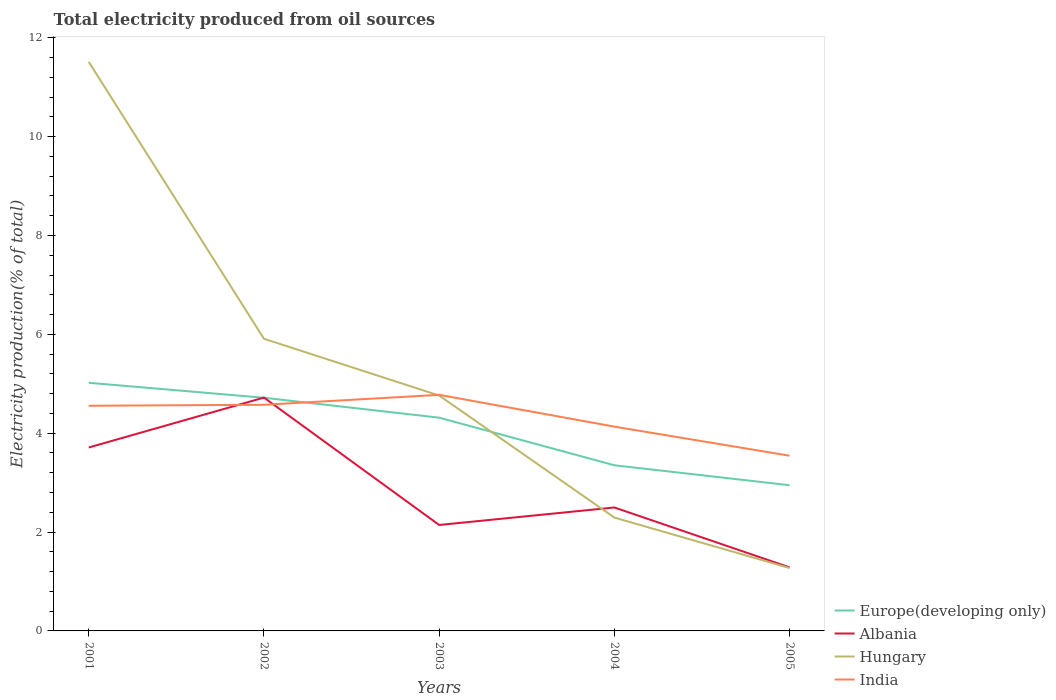Does the line corresponding to Europe(developing only) intersect with the line corresponding to Hungary?
Offer a very short reply. Yes. Is the number of lines equal to the number of legend labels?
Provide a short and direct response. Yes. Across all years, what is the maximum total electricity produced in India?
Offer a terse response. 3.54. In which year was the total electricity produced in Hungary maximum?
Keep it short and to the point. 2005. What is the total total electricity produced in India in the graph?
Offer a terse response. 0.64. What is the difference between the highest and the second highest total electricity produced in India?
Provide a succinct answer. 1.23. What is the difference between the highest and the lowest total electricity produced in Albania?
Make the answer very short. 2. Is the total electricity produced in Albania strictly greater than the total electricity produced in India over the years?
Your answer should be very brief. No. How many years are there in the graph?
Your answer should be compact. 5. What is the difference between two consecutive major ticks on the Y-axis?
Keep it short and to the point. 2. Are the values on the major ticks of Y-axis written in scientific E-notation?
Your answer should be very brief. No. Does the graph contain any zero values?
Your answer should be very brief. No. Where does the legend appear in the graph?
Ensure brevity in your answer.  Bottom right. How many legend labels are there?
Give a very brief answer. 4. What is the title of the graph?
Offer a terse response. Total electricity produced from oil sources. Does "San Marino" appear as one of the legend labels in the graph?
Provide a short and direct response. No. What is the label or title of the X-axis?
Ensure brevity in your answer.  Years. What is the Electricity production(% of total) in Europe(developing only) in 2001?
Your answer should be very brief. 5.02. What is the Electricity production(% of total) in Albania in 2001?
Give a very brief answer. 3.71. What is the Electricity production(% of total) of Hungary in 2001?
Give a very brief answer. 11.51. What is the Electricity production(% of total) in India in 2001?
Offer a very short reply. 4.55. What is the Electricity production(% of total) in Europe(developing only) in 2002?
Keep it short and to the point. 4.72. What is the Electricity production(% of total) in Albania in 2002?
Make the answer very short. 4.72. What is the Electricity production(% of total) in Hungary in 2002?
Keep it short and to the point. 5.91. What is the Electricity production(% of total) in India in 2002?
Your response must be concise. 4.57. What is the Electricity production(% of total) of Europe(developing only) in 2003?
Make the answer very short. 4.31. What is the Electricity production(% of total) of Albania in 2003?
Keep it short and to the point. 2.14. What is the Electricity production(% of total) of Hungary in 2003?
Give a very brief answer. 4.76. What is the Electricity production(% of total) in India in 2003?
Your answer should be compact. 4.78. What is the Electricity production(% of total) of Europe(developing only) in 2004?
Keep it short and to the point. 3.35. What is the Electricity production(% of total) in Albania in 2004?
Offer a very short reply. 2.5. What is the Electricity production(% of total) of Hungary in 2004?
Offer a very short reply. 2.29. What is the Electricity production(% of total) in India in 2004?
Your answer should be compact. 4.13. What is the Electricity production(% of total) of Europe(developing only) in 2005?
Offer a very short reply. 2.95. What is the Electricity production(% of total) of Albania in 2005?
Your answer should be compact. 1.29. What is the Electricity production(% of total) in Hungary in 2005?
Provide a short and direct response. 1.27. What is the Electricity production(% of total) in India in 2005?
Provide a short and direct response. 3.54. Across all years, what is the maximum Electricity production(% of total) in Europe(developing only)?
Offer a terse response. 5.02. Across all years, what is the maximum Electricity production(% of total) of Albania?
Provide a succinct answer. 4.72. Across all years, what is the maximum Electricity production(% of total) in Hungary?
Offer a very short reply. 11.51. Across all years, what is the maximum Electricity production(% of total) of India?
Give a very brief answer. 4.78. Across all years, what is the minimum Electricity production(% of total) in Europe(developing only)?
Offer a terse response. 2.95. Across all years, what is the minimum Electricity production(% of total) in Albania?
Make the answer very short. 1.29. Across all years, what is the minimum Electricity production(% of total) of Hungary?
Your answer should be very brief. 1.27. Across all years, what is the minimum Electricity production(% of total) of India?
Provide a succinct answer. 3.54. What is the total Electricity production(% of total) of Europe(developing only) in the graph?
Your response must be concise. 20.35. What is the total Electricity production(% of total) of Albania in the graph?
Your answer should be compact. 14.36. What is the total Electricity production(% of total) of Hungary in the graph?
Your answer should be very brief. 25.75. What is the total Electricity production(% of total) in India in the graph?
Provide a short and direct response. 21.58. What is the difference between the Electricity production(% of total) in Europe(developing only) in 2001 and that in 2002?
Your answer should be very brief. 0.3. What is the difference between the Electricity production(% of total) in Albania in 2001 and that in 2002?
Offer a very short reply. -1.01. What is the difference between the Electricity production(% of total) in Hungary in 2001 and that in 2002?
Your response must be concise. 5.6. What is the difference between the Electricity production(% of total) in India in 2001 and that in 2002?
Your answer should be very brief. -0.02. What is the difference between the Electricity production(% of total) of Europe(developing only) in 2001 and that in 2003?
Ensure brevity in your answer.  0.71. What is the difference between the Electricity production(% of total) of Albania in 2001 and that in 2003?
Keep it short and to the point. 1.57. What is the difference between the Electricity production(% of total) of Hungary in 2001 and that in 2003?
Offer a very short reply. 6.75. What is the difference between the Electricity production(% of total) in India in 2001 and that in 2003?
Offer a very short reply. -0.22. What is the difference between the Electricity production(% of total) in Europe(developing only) in 2001 and that in 2004?
Provide a short and direct response. 1.67. What is the difference between the Electricity production(% of total) in Albania in 2001 and that in 2004?
Offer a very short reply. 1.21. What is the difference between the Electricity production(% of total) of Hungary in 2001 and that in 2004?
Keep it short and to the point. 9.22. What is the difference between the Electricity production(% of total) of India in 2001 and that in 2004?
Give a very brief answer. 0.42. What is the difference between the Electricity production(% of total) of Europe(developing only) in 2001 and that in 2005?
Your response must be concise. 2.07. What is the difference between the Electricity production(% of total) of Albania in 2001 and that in 2005?
Give a very brief answer. 2.42. What is the difference between the Electricity production(% of total) in Hungary in 2001 and that in 2005?
Keep it short and to the point. 10.24. What is the difference between the Electricity production(% of total) in India in 2001 and that in 2005?
Your response must be concise. 1.01. What is the difference between the Electricity production(% of total) of Europe(developing only) in 2002 and that in 2003?
Your answer should be very brief. 0.4. What is the difference between the Electricity production(% of total) in Albania in 2002 and that in 2003?
Offer a terse response. 2.58. What is the difference between the Electricity production(% of total) in Hungary in 2002 and that in 2003?
Provide a succinct answer. 1.15. What is the difference between the Electricity production(% of total) of India in 2002 and that in 2003?
Keep it short and to the point. -0.2. What is the difference between the Electricity production(% of total) of Europe(developing only) in 2002 and that in 2004?
Keep it short and to the point. 1.37. What is the difference between the Electricity production(% of total) of Albania in 2002 and that in 2004?
Your answer should be very brief. 2.22. What is the difference between the Electricity production(% of total) of Hungary in 2002 and that in 2004?
Give a very brief answer. 3.62. What is the difference between the Electricity production(% of total) of India in 2002 and that in 2004?
Give a very brief answer. 0.44. What is the difference between the Electricity production(% of total) of Europe(developing only) in 2002 and that in 2005?
Provide a short and direct response. 1.77. What is the difference between the Electricity production(% of total) in Albania in 2002 and that in 2005?
Give a very brief answer. 3.43. What is the difference between the Electricity production(% of total) in Hungary in 2002 and that in 2005?
Offer a terse response. 4.64. What is the difference between the Electricity production(% of total) in India in 2002 and that in 2005?
Ensure brevity in your answer.  1.03. What is the difference between the Electricity production(% of total) of Albania in 2003 and that in 2004?
Provide a short and direct response. -0.35. What is the difference between the Electricity production(% of total) of Hungary in 2003 and that in 2004?
Give a very brief answer. 2.47. What is the difference between the Electricity production(% of total) in India in 2003 and that in 2004?
Keep it short and to the point. 0.64. What is the difference between the Electricity production(% of total) in Europe(developing only) in 2003 and that in 2005?
Offer a very short reply. 1.37. What is the difference between the Electricity production(% of total) in Albania in 2003 and that in 2005?
Keep it short and to the point. 0.86. What is the difference between the Electricity production(% of total) in Hungary in 2003 and that in 2005?
Give a very brief answer. 3.49. What is the difference between the Electricity production(% of total) in India in 2003 and that in 2005?
Ensure brevity in your answer.  1.23. What is the difference between the Electricity production(% of total) in Europe(developing only) in 2004 and that in 2005?
Your answer should be very brief. 0.4. What is the difference between the Electricity production(% of total) of Albania in 2004 and that in 2005?
Give a very brief answer. 1.21. What is the difference between the Electricity production(% of total) in Hungary in 2004 and that in 2005?
Your response must be concise. 1.02. What is the difference between the Electricity production(% of total) in India in 2004 and that in 2005?
Keep it short and to the point. 0.59. What is the difference between the Electricity production(% of total) in Europe(developing only) in 2001 and the Electricity production(% of total) in Albania in 2002?
Make the answer very short. 0.3. What is the difference between the Electricity production(% of total) in Europe(developing only) in 2001 and the Electricity production(% of total) in Hungary in 2002?
Your answer should be very brief. -0.89. What is the difference between the Electricity production(% of total) in Europe(developing only) in 2001 and the Electricity production(% of total) in India in 2002?
Your response must be concise. 0.45. What is the difference between the Electricity production(% of total) of Albania in 2001 and the Electricity production(% of total) of Hungary in 2002?
Your response must be concise. -2.2. What is the difference between the Electricity production(% of total) in Albania in 2001 and the Electricity production(% of total) in India in 2002?
Make the answer very short. -0.86. What is the difference between the Electricity production(% of total) of Hungary in 2001 and the Electricity production(% of total) of India in 2002?
Provide a short and direct response. 6.94. What is the difference between the Electricity production(% of total) in Europe(developing only) in 2001 and the Electricity production(% of total) in Albania in 2003?
Keep it short and to the point. 2.88. What is the difference between the Electricity production(% of total) in Europe(developing only) in 2001 and the Electricity production(% of total) in Hungary in 2003?
Offer a terse response. 0.26. What is the difference between the Electricity production(% of total) in Europe(developing only) in 2001 and the Electricity production(% of total) in India in 2003?
Your response must be concise. 0.24. What is the difference between the Electricity production(% of total) of Albania in 2001 and the Electricity production(% of total) of Hungary in 2003?
Your response must be concise. -1.05. What is the difference between the Electricity production(% of total) of Albania in 2001 and the Electricity production(% of total) of India in 2003?
Keep it short and to the point. -1.07. What is the difference between the Electricity production(% of total) of Hungary in 2001 and the Electricity production(% of total) of India in 2003?
Offer a terse response. 6.74. What is the difference between the Electricity production(% of total) of Europe(developing only) in 2001 and the Electricity production(% of total) of Albania in 2004?
Give a very brief answer. 2.52. What is the difference between the Electricity production(% of total) in Europe(developing only) in 2001 and the Electricity production(% of total) in Hungary in 2004?
Offer a terse response. 2.73. What is the difference between the Electricity production(% of total) in Europe(developing only) in 2001 and the Electricity production(% of total) in India in 2004?
Your response must be concise. 0.89. What is the difference between the Electricity production(% of total) in Albania in 2001 and the Electricity production(% of total) in Hungary in 2004?
Give a very brief answer. 1.42. What is the difference between the Electricity production(% of total) of Albania in 2001 and the Electricity production(% of total) of India in 2004?
Make the answer very short. -0.42. What is the difference between the Electricity production(% of total) of Hungary in 2001 and the Electricity production(% of total) of India in 2004?
Your response must be concise. 7.38. What is the difference between the Electricity production(% of total) of Europe(developing only) in 2001 and the Electricity production(% of total) of Albania in 2005?
Give a very brief answer. 3.73. What is the difference between the Electricity production(% of total) of Europe(developing only) in 2001 and the Electricity production(% of total) of Hungary in 2005?
Provide a succinct answer. 3.75. What is the difference between the Electricity production(% of total) of Europe(developing only) in 2001 and the Electricity production(% of total) of India in 2005?
Your response must be concise. 1.48. What is the difference between the Electricity production(% of total) in Albania in 2001 and the Electricity production(% of total) in Hungary in 2005?
Offer a terse response. 2.44. What is the difference between the Electricity production(% of total) in Albania in 2001 and the Electricity production(% of total) in India in 2005?
Provide a succinct answer. 0.17. What is the difference between the Electricity production(% of total) of Hungary in 2001 and the Electricity production(% of total) of India in 2005?
Offer a terse response. 7.97. What is the difference between the Electricity production(% of total) of Europe(developing only) in 2002 and the Electricity production(% of total) of Albania in 2003?
Keep it short and to the point. 2.57. What is the difference between the Electricity production(% of total) in Europe(developing only) in 2002 and the Electricity production(% of total) in Hungary in 2003?
Your answer should be very brief. -0.04. What is the difference between the Electricity production(% of total) in Europe(developing only) in 2002 and the Electricity production(% of total) in India in 2003?
Your response must be concise. -0.06. What is the difference between the Electricity production(% of total) of Albania in 2002 and the Electricity production(% of total) of Hungary in 2003?
Provide a short and direct response. -0.04. What is the difference between the Electricity production(% of total) of Albania in 2002 and the Electricity production(% of total) of India in 2003?
Your answer should be compact. -0.06. What is the difference between the Electricity production(% of total) in Hungary in 2002 and the Electricity production(% of total) in India in 2003?
Give a very brief answer. 1.13. What is the difference between the Electricity production(% of total) in Europe(developing only) in 2002 and the Electricity production(% of total) in Albania in 2004?
Provide a succinct answer. 2.22. What is the difference between the Electricity production(% of total) in Europe(developing only) in 2002 and the Electricity production(% of total) in Hungary in 2004?
Your response must be concise. 2.42. What is the difference between the Electricity production(% of total) of Europe(developing only) in 2002 and the Electricity production(% of total) of India in 2004?
Keep it short and to the point. 0.58. What is the difference between the Electricity production(% of total) in Albania in 2002 and the Electricity production(% of total) in Hungary in 2004?
Keep it short and to the point. 2.43. What is the difference between the Electricity production(% of total) of Albania in 2002 and the Electricity production(% of total) of India in 2004?
Your answer should be compact. 0.59. What is the difference between the Electricity production(% of total) of Hungary in 2002 and the Electricity production(% of total) of India in 2004?
Offer a very short reply. 1.78. What is the difference between the Electricity production(% of total) of Europe(developing only) in 2002 and the Electricity production(% of total) of Albania in 2005?
Your answer should be very brief. 3.43. What is the difference between the Electricity production(% of total) of Europe(developing only) in 2002 and the Electricity production(% of total) of Hungary in 2005?
Provide a succinct answer. 3.44. What is the difference between the Electricity production(% of total) of Europe(developing only) in 2002 and the Electricity production(% of total) of India in 2005?
Keep it short and to the point. 1.17. What is the difference between the Electricity production(% of total) in Albania in 2002 and the Electricity production(% of total) in Hungary in 2005?
Your answer should be very brief. 3.45. What is the difference between the Electricity production(% of total) in Albania in 2002 and the Electricity production(% of total) in India in 2005?
Provide a succinct answer. 1.18. What is the difference between the Electricity production(% of total) in Hungary in 2002 and the Electricity production(% of total) in India in 2005?
Your answer should be very brief. 2.37. What is the difference between the Electricity production(% of total) of Europe(developing only) in 2003 and the Electricity production(% of total) of Albania in 2004?
Provide a succinct answer. 1.82. What is the difference between the Electricity production(% of total) of Europe(developing only) in 2003 and the Electricity production(% of total) of Hungary in 2004?
Your answer should be compact. 2.02. What is the difference between the Electricity production(% of total) of Europe(developing only) in 2003 and the Electricity production(% of total) of India in 2004?
Your response must be concise. 0.18. What is the difference between the Electricity production(% of total) in Albania in 2003 and the Electricity production(% of total) in Hungary in 2004?
Give a very brief answer. -0.15. What is the difference between the Electricity production(% of total) in Albania in 2003 and the Electricity production(% of total) in India in 2004?
Give a very brief answer. -1.99. What is the difference between the Electricity production(% of total) in Hungary in 2003 and the Electricity production(% of total) in India in 2004?
Provide a short and direct response. 0.63. What is the difference between the Electricity production(% of total) in Europe(developing only) in 2003 and the Electricity production(% of total) in Albania in 2005?
Your answer should be compact. 3.03. What is the difference between the Electricity production(% of total) of Europe(developing only) in 2003 and the Electricity production(% of total) of Hungary in 2005?
Keep it short and to the point. 3.04. What is the difference between the Electricity production(% of total) in Europe(developing only) in 2003 and the Electricity production(% of total) in India in 2005?
Offer a terse response. 0.77. What is the difference between the Electricity production(% of total) in Albania in 2003 and the Electricity production(% of total) in Hungary in 2005?
Your answer should be compact. 0.87. What is the difference between the Electricity production(% of total) in Albania in 2003 and the Electricity production(% of total) in India in 2005?
Keep it short and to the point. -1.4. What is the difference between the Electricity production(% of total) in Hungary in 2003 and the Electricity production(% of total) in India in 2005?
Offer a terse response. 1.22. What is the difference between the Electricity production(% of total) in Europe(developing only) in 2004 and the Electricity production(% of total) in Albania in 2005?
Keep it short and to the point. 2.07. What is the difference between the Electricity production(% of total) of Europe(developing only) in 2004 and the Electricity production(% of total) of Hungary in 2005?
Your answer should be compact. 2.08. What is the difference between the Electricity production(% of total) of Europe(developing only) in 2004 and the Electricity production(% of total) of India in 2005?
Give a very brief answer. -0.19. What is the difference between the Electricity production(% of total) in Albania in 2004 and the Electricity production(% of total) in Hungary in 2005?
Give a very brief answer. 1.22. What is the difference between the Electricity production(% of total) in Albania in 2004 and the Electricity production(% of total) in India in 2005?
Offer a terse response. -1.05. What is the difference between the Electricity production(% of total) of Hungary in 2004 and the Electricity production(% of total) of India in 2005?
Give a very brief answer. -1.25. What is the average Electricity production(% of total) of Europe(developing only) per year?
Provide a succinct answer. 4.07. What is the average Electricity production(% of total) of Albania per year?
Your answer should be very brief. 2.87. What is the average Electricity production(% of total) in Hungary per year?
Your answer should be compact. 5.15. What is the average Electricity production(% of total) of India per year?
Give a very brief answer. 4.32. In the year 2001, what is the difference between the Electricity production(% of total) in Europe(developing only) and Electricity production(% of total) in Albania?
Provide a short and direct response. 1.31. In the year 2001, what is the difference between the Electricity production(% of total) in Europe(developing only) and Electricity production(% of total) in Hungary?
Your response must be concise. -6.49. In the year 2001, what is the difference between the Electricity production(% of total) in Europe(developing only) and Electricity production(% of total) in India?
Keep it short and to the point. 0.46. In the year 2001, what is the difference between the Electricity production(% of total) of Albania and Electricity production(% of total) of Hungary?
Provide a succinct answer. -7.8. In the year 2001, what is the difference between the Electricity production(% of total) of Albania and Electricity production(% of total) of India?
Your response must be concise. -0.84. In the year 2001, what is the difference between the Electricity production(% of total) of Hungary and Electricity production(% of total) of India?
Ensure brevity in your answer.  6.96. In the year 2002, what is the difference between the Electricity production(% of total) in Europe(developing only) and Electricity production(% of total) in Albania?
Make the answer very short. -0. In the year 2002, what is the difference between the Electricity production(% of total) in Europe(developing only) and Electricity production(% of total) in Hungary?
Provide a short and direct response. -1.19. In the year 2002, what is the difference between the Electricity production(% of total) of Europe(developing only) and Electricity production(% of total) of India?
Provide a short and direct response. 0.14. In the year 2002, what is the difference between the Electricity production(% of total) of Albania and Electricity production(% of total) of Hungary?
Your answer should be very brief. -1.19. In the year 2002, what is the difference between the Electricity production(% of total) in Albania and Electricity production(% of total) in India?
Keep it short and to the point. 0.15. In the year 2002, what is the difference between the Electricity production(% of total) in Hungary and Electricity production(% of total) in India?
Your answer should be compact. 1.34. In the year 2003, what is the difference between the Electricity production(% of total) in Europe(developing only) and Electricity production(% of total) in Albania?
Give a very brief answer. 2.17. In the year 2003, what is the difference between the Electricity production(% of total) of Europe(developing only) and Electricity production(% of total) of Hungary?
Give a very brief answer. -0.45. In the year 2003, what is the difference between the Electricity production(% of total) in Europe(developing only) and Electricity production(% of total) in India?
Ensure brevity in your answer.  -0.46. In the year 2003, what is the difference between the Electricity production(% of total) of Albania and Electricity production(% of total) of Hungary?
Make the answer very short. -2.62. In the year 2003, what is the difference between the Electricity production(% of total) in Albania and Electricity production(% of total) in India?
Make the answer very short. -2.63. In the year 2003, what is the difference between the Electricity production(% of total) of Hungary and Electricity production(% of total) of India?
Give a very brief answer. -0.01. In the year 2004, what is the difference between the Electricity production(% of total) in Europe(developing only) and Electricity production(% of total) in Albania?
Offer a terse response. 0.85. In the year 2004, what is the difference between the Electricity production(% of total) in Europe(developing only) and Electricity production(% of total) in Hungary?
Your answer should be very brief. 1.06. In the year 2004, what is the difference between the Electricity production(% of total) of Europe(developing only) and Electricity production(% of total) of India?
Offer a very short reply. -0.78. In the year 2004, what is the difference between the Electricity production(% of total) in Albania and Electricity production(% of total) in Hungary?
Offer a terse response. 0.2. In the year 2004, what is the difference between the Electricity production(% of total) of Albania and Electricity production(% of total) of India?
Your answer should be compact. -1.64. In the year 2004, what is the difference between the Electricity production(% of total) of Hungary and Electricity production(% of total) of India?
Make the answer very short. -1.84. In the year 2005, what is the difference between the Electricity production(% of total) in Europe(developing only) and Electricity production(% of total) in Albania?
Keep it short and to the point. 1.66. In the year 2005, what is the difference between the Electricity production(% of total) of Europe(developing only) and Electricity production(% of total) of Hungary?
Provide a short and direct response. 1.68. In the year 2005, what is the difference between the Electricity production(% of total) of Europe(developing only) and Electricity production(% of total) of India?
Provide a short and direct response. -0.6. In the year 2005, what is the difference between the Electricity production(% of total) of Albania and Electricity production(% of total) of Hungary?
Keep it short and to the point. 0.01. In the year 2005, what is the difference between the Electricity production(% of total) in Albania and Electricity production(% of total) in India?
Provide a succinct answer. -2.26. In the year 2005, what is the difference between the Electricity production(% of total) in Hungary and Electricity production(% of total) in India?
Offer a terse response. -2.27. What is the ratio of the Electricity production(% of total) of Europe(developing only) in 2001 to that in 2002?
Offer a terse response. 1.06. What is the ratio of the Electricity production(% of total) in Albania in 2001 to that in 2002?
Keep it short and to the point. 0.79. What is the ratio of the Electricity production(% of total) of Hungary in 2001 to that in 2002?
Provide a succinct answer. 1.95. What is the ratio of the Electricity production(% of total) of Europe(developing only) in 2001 to that in 2003?
Your answer should be very brief. 1.16. What is the ratio of the Electricity production(% of total) in Albania in 2001 to that in 2003?
Your response must be concise. 1.73. What is the ratio of the Electricity production(% of total) of Hungary in 2001 to that in 2003?
Offer a terse response. 2.42. What is the ratio of the Electricity production(% of total) in India in 2001 to that in 2003?
Provide a succinct answer. 0.95. What is the ratio of the Electricity production(% of total) of Europe(developing only) in 2001 to that in 2004?
Keep it short and to the point. 1.5. What is the ratio of the Electricity production(% of total) in Albania in 2001 to that in 2004?
Provide a short and direct response. 1.49. What is the ratio of the Electricity production(% of total) of Hungary in 2001 to that in 2004?
Keep it short and to the point. 5.02. What is the ratio of the Electricity production(% of total) of India in 2001 to that in 2004?
Keep it short and to the point. 1.1. What is the ratio of the Electricity production(% of total) in Europe(developing only) in 2001 to that in 2005?
Provide a short and direct response. 1.7. What is the ratio of the Electricity production(% of total) in Albania in 2001 to that in 2005?
Give a very brief answer. 2.89. What is the ratio of the Electricity production(% of total) of Hungary in 2001 to that in 2005?
Offer a very short reply. 9.05. What is the ratio of the Electricity production(% of total) of India in 2001 to that in 2005?
Provide a succinct answer. 1.29. What is the ratio of the Electricity production(% of total) of Europe(developing only) in 2002 to that in 2003?
Keep it short and to the point. 1.09. What is the ratio of the Electricity production(% of total) in Albania in 2002 to that in 2003?
Your answer should be compact. 2.2. What is the ratio of the Electricity production(% of total) in Hungary in 2002 to that in 2003?
Make the answer very short. 1.24. What is the ratio of the Electricity production(% of total) in India in 2002 to that in 2003?
Your answer should be very brief. 0.96. What is the ratio of the Electricity production(% of total) of Europe(developing only) in 2002 to that in 2004?
Ensure brevity in your answer.  1.41. What is the ratio of the Electricity production(% of total) in Albania in 2002 to that in 2004?
Provide a succinct answer. 1.89. What is the ratio of the Electricity production(% of total) in Hungary in 2002 to that in 2004?
Make the answer very short. 2.58. What is the ratio of the Electricity production(% of total) of India in 2002 to that in 2004?
Offer a very short reply. 1.11. What is the ratio of the Electricity production(% of total) of Europe(developing only) in 2002 to that in 2005?
Your response must be concise. 1.6. What is the ratio of the Electricity production(% of total) in Albania in 2002 to that in 2005?
Offer a terse response. 3.67. What is the ratio of the Electricity production(% of total) of Hungary in 2002 to that in 2005?
Provide a short and direct response. 4.64. What is the ratio of the Electricity production(% of total) of India in 2002 to that in 2005?
Give a very brief answer. 1.29. What is the ratio of the Electricity production(% of total) of Europe(developing only) in 2003 to that in 2004?
Ensure brevity in your answer.  1.29. What is the ratio of the Electricity production(% of total) of Albania in 2003 to that in 2004?
Provide a short and direct response. 0.86. What is the ratio of the Electricity production(% of total) in Hungary in 2003 to that in 2004?
Provide a succinct answer. 2.08. What is the ratio of the Electricity production(% of total) in India in 2003 to that in 2004?
Your answer should be very brief. 1.16. What is the ratio of the Electricity production(% of total) in Europe(developing only) in 2003 to that in 2005?
Make the answer very short. 1.46. What is the ratio of the Electricity production(% of total) of Hungary in 2003 to that in 2005?
Offer a terse response. 3.74. What is the ratio of the Electricity production(% of total) in India in 2003 to that in 2005?
Keep it short and to the point. 1.35. What is the ratio of the Electricity production(% of total) in Europe(developing only) in 2004 to that in 2005?
Make the answer very short. 1.14. What is the ratio of the Electricity production(% of total) of Albania in 2004 to that in 2005?
Your answer should be very brief. 1.94. What is the ratio of the Electricity production(% of total) in Hungary in 2004 to that in 2005?
Your response must be concise. 1.8. What is the ratio of the Electricity production(% of total) in India in 2004 to that in 2005?
Offer a very short reply. 1.17. What is the difference between the highest and the second highest Electricity production(% of total) of Europe(developing only)?
Your response must be concise. 0.3. What is the difference between the highest and the second highest Electricity production(% of total) in Albania?
Offer a terse response. 1.01. What is the difference between the highest and the second highest Electricity production(% of total) in Hungary?
Give a very brief answer. 5.6. What is the difference between the highest and the second highest Electricity production(% of total) of India?
Offer a very short reply. 0.2. What is the difference between the highest and the lowest Electricity production(% of total) in Europe(developing only)?
Your answer should be very brief. 2.07. What is the difference between the highest and the lowest Electricity production(% of total) of Albania?
Keep it short and to the point. 3.43. What is the difference between the highest and the lowest Electricity production(% of total) in Hungary?
Give a very brief answer. 10.24. What is the difference between the highest and the lowest Electricity production(% of total) in India?
Make the answer very short. 1.23. 